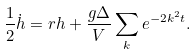Convert formula to latex. <formula><loc_0><loc_0><loc_500><loc_500>\frac { 1 } { 2 } \dot { h } = r h + \frac { g \Delta } { V } \sum _ { k } e ^ { - 2 k ^ { 2 } t } .</formula> 